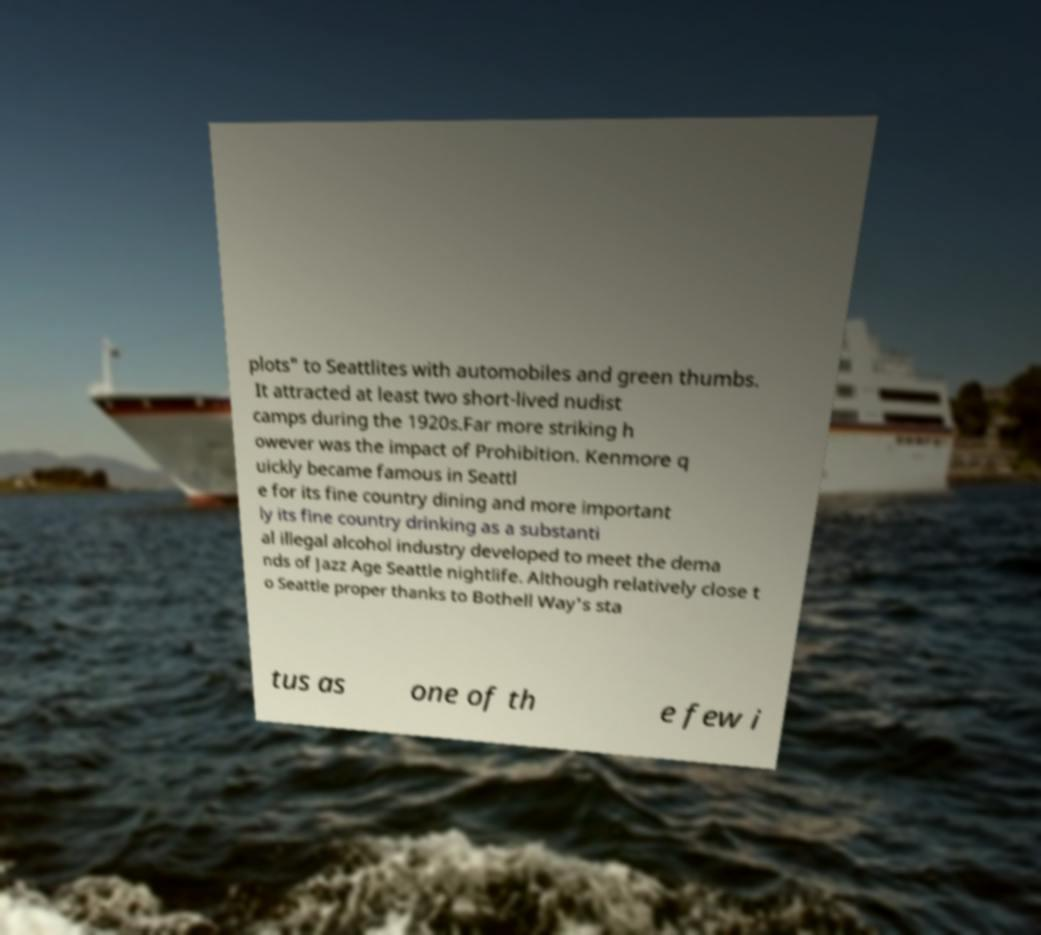What messages or text are displayed in this image? I need them in a readable, typed format. plots" to Seattlites with automobiles and green thumbs. It attracted at least two short-lived nudist camps during the 1920s.Far more striking h owever was the impact of Prohibition. Kenmore q uickly became famous in Seattl e for its fine country dining and more important ly its fine country drinking as a substanti al illegal alcohol industry developed to meet the dema nds of Jazz Age Seattle nightlife. Although relatively close t o Seattle proper thanks to Bothell Way's sta tus as one of th e few i 